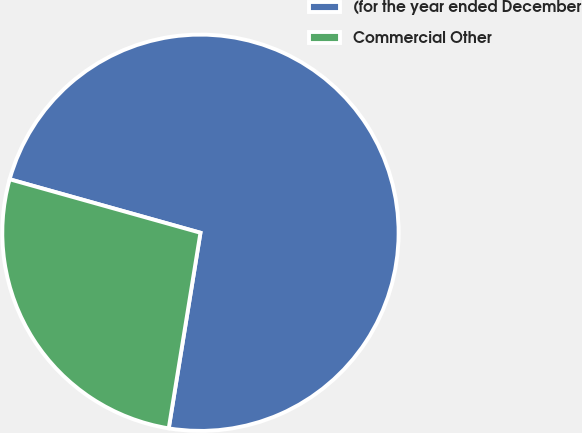Convert chart. <chart><loc_0><loc_0><loc_500><loc_500><pie_chart><fcel>(for the year ended December<fcel>Commercial Other<nl><fcel>73.21%<fcel>26.79%<nl></chart> 